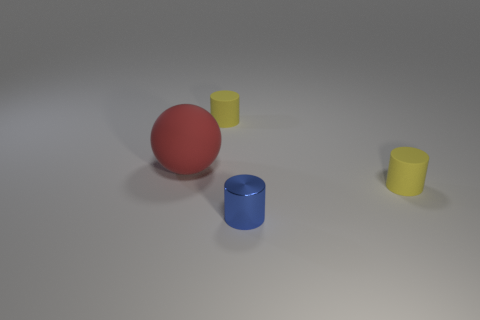Add 4 tiny blue shiny objects. How many objects exist? 8 Subtract 1 blue cylinders. How many objects are left? 3 Subtract all spheres. How many objects are left? 3 Subtract all large objects. Subtract all large red balls. How many objects are left? 2 Add 3 cylinders. How many cylinders are left? 6 Add 2 big gray rubber cubes. How many big gray rubber cubes exist? 2 